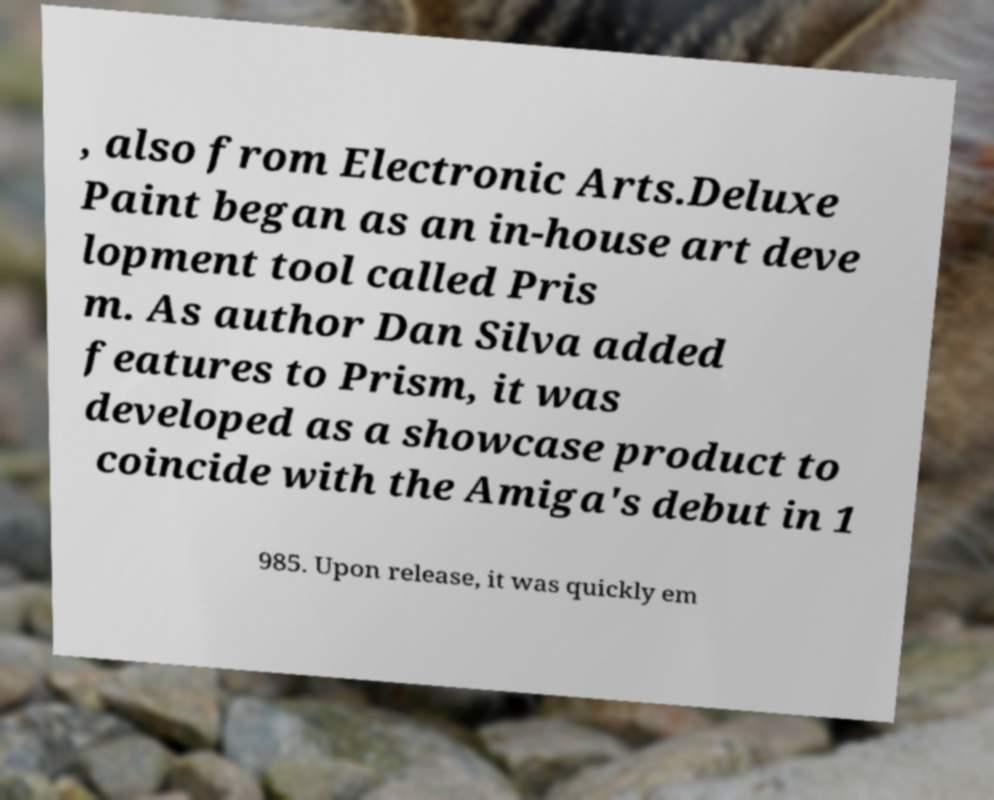What messages or text are displayed in this image? I need them in a readable, typed format. , also from Electronic Arts.Deluxe Paint began as an in-house art deve lopment tool called Pris m. As author Dan Silva added features to Prism, it was developed as a showcase product to coincide with the Amiga's debut in 1 985. Upon release, it was quickly em 